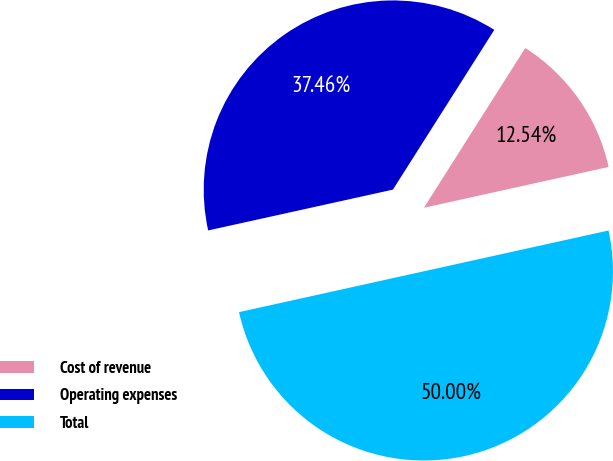Convert chart. <chart><loc_0><loc_0><loc_500><loc_500><pie_chart><fcel>Cost of revenue<fcel>Operating expenses<fcel>Total<nl><fcel>12.54%<fcel>37.46%<fcel>50.0%<nl></chart> 